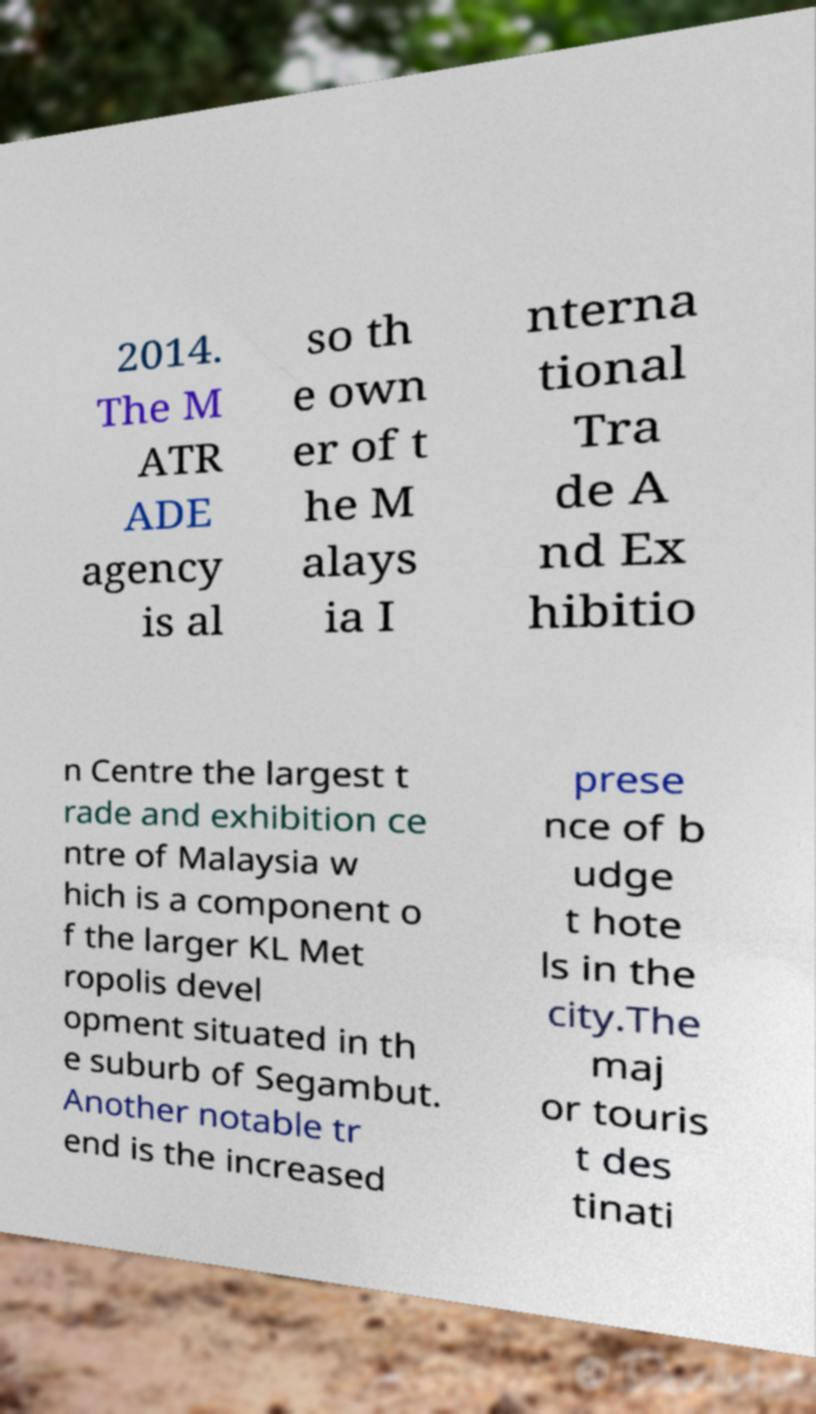Can you read and provide the text displayed in the image?This photo seems to have some interesting text. Can you extract and type it out for me? 2014. The M ATR ADE agency is al so th e own er of t he M alays ia I nterna tional Tra de A nd Ex hibitio n Centre the largest t rade and exhibition ce ntre of Malaysia w hich is a component o f the larger KL Met ropolis devel opment situated in th e suburb of Segambut. Another notable tr end is the increased prese nce of b udge t hote ls in the city.The maj or touris t des tinati 